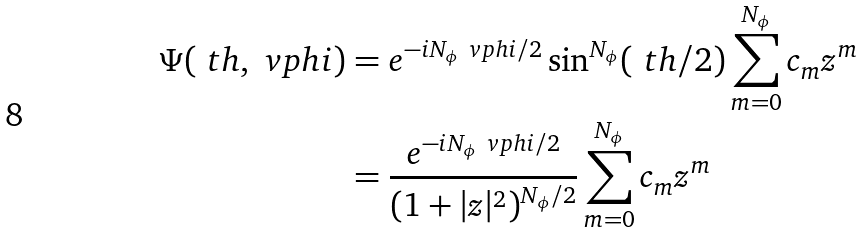<formula> <loc_0><loc_0><loc_500><loc_500>\Psi ( \ t h , \ v p h i ) & = e ^ { - i N _ { \phi } \ v p h i / 2 } \sin ^ { N _ { \phi } } ( \ t h / 2 ) \sum _ { m = 0 } ^ { N _ { \phi } } c _ { m } z ^ { m } \\ & = \frac { e ^ { - i N _ { \phi } \ v p h i / 2 } } { ( 1 + | z | ^ { 2 } ) ^ { N _ { \phi } / 2 } } \sum _ { m = 0 } ^ { N _ { \phi } } c _ { m } z ^ { m }</formula> 